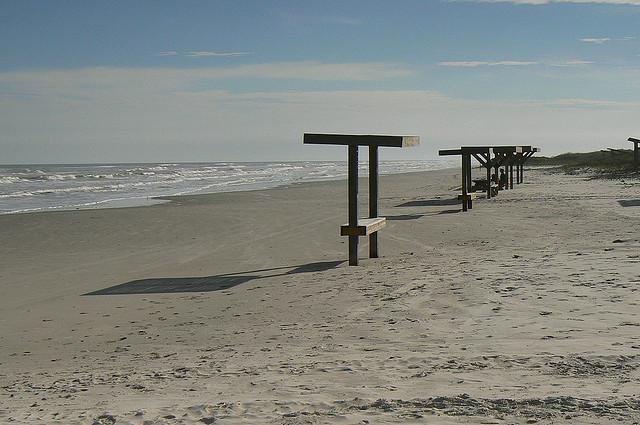How many boats are in the picture?
Give a very brief answer. 0. How many train tracks are in this photo?
Give a very brief answer. 0. 